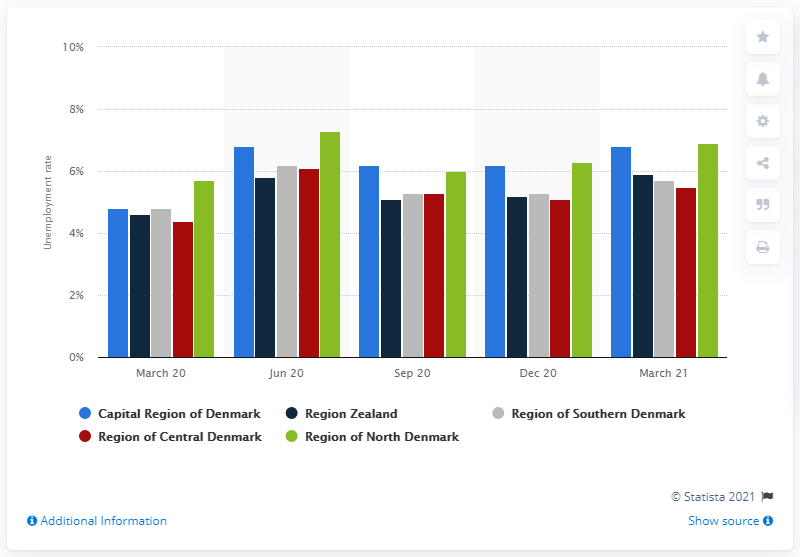Indicate a few pertinent items in this graphic. The unemployment rate in the Capital Region of Denmark between March 2020 and March 2021 was 4.8%. The unemployment rate in the Region of North Denmark from March 2020 to March 2021 was 6.9%. 